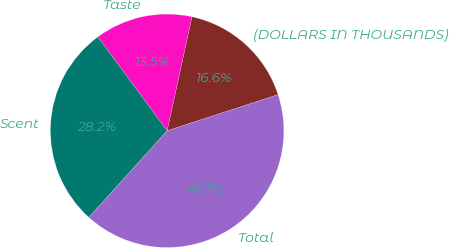Convert chart to OTSL. <chart><loc_0><loc_0><loc_500><loc_500><pie_chart><fcel>(DOLLARS IN THOUSANDS)<fcel>Taste<fcel>Scent<fcel>Total<nl><fcel>16.57%<fcel>13.52%<fcel>28.19%<fcel>41.71%<nl></chart> 